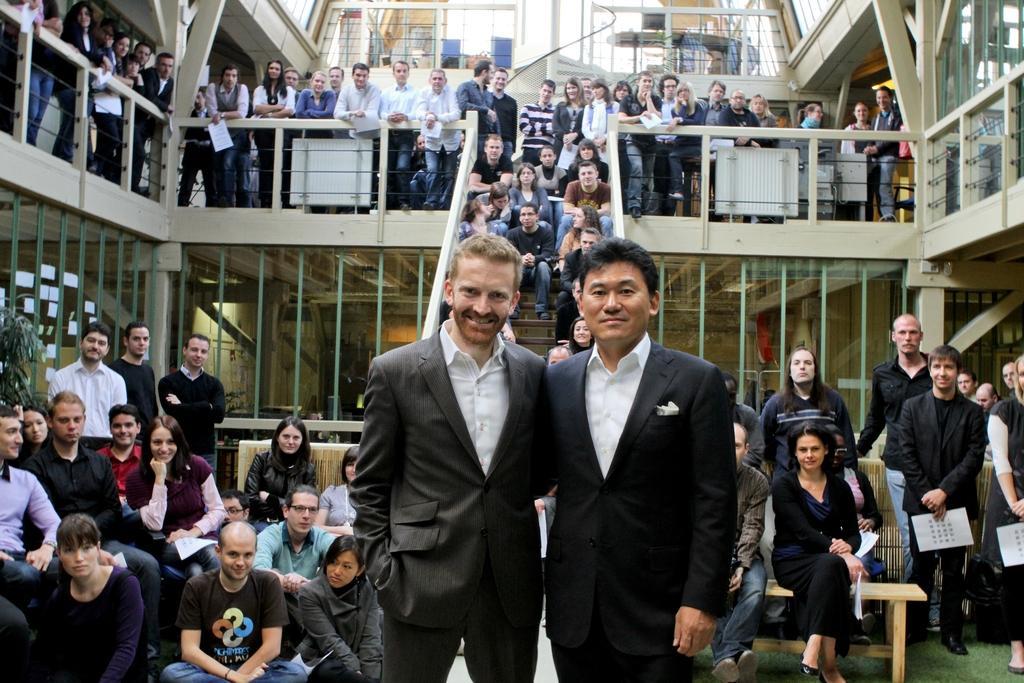Describe this image in one or two sentences. In this image there are group of persons standing sitting and smiling. On the left side there are leaves. On the ground is grass. In the center there is a staircase and there are persons sitting on staircase. In the background there are glass walls. 